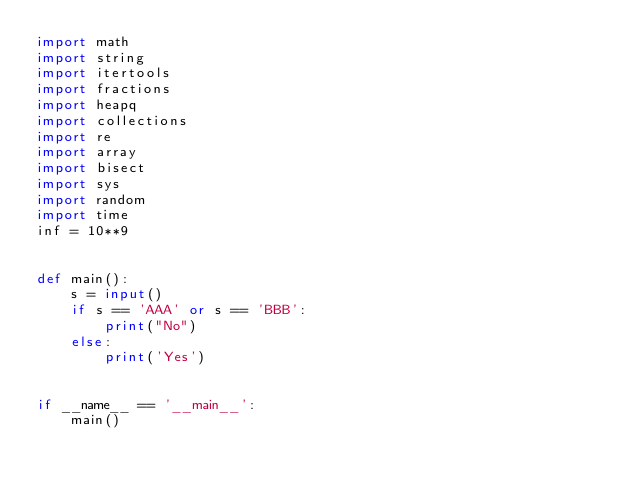Convert code to text. <code><loc_0><loc_0><loc_500><loc_500><_Python_>import math
import string
import itertools
import fractions
import heapq
import collections
import re
import array
import bisect
import sys
import random
import time
inf = 10**9


def main():
    s = input()
    if s == 'AAA' or s == 'BBB':
        print("No")
    else:
        print('Yes')


if __name__ == '__main__':
    main()
</code> 